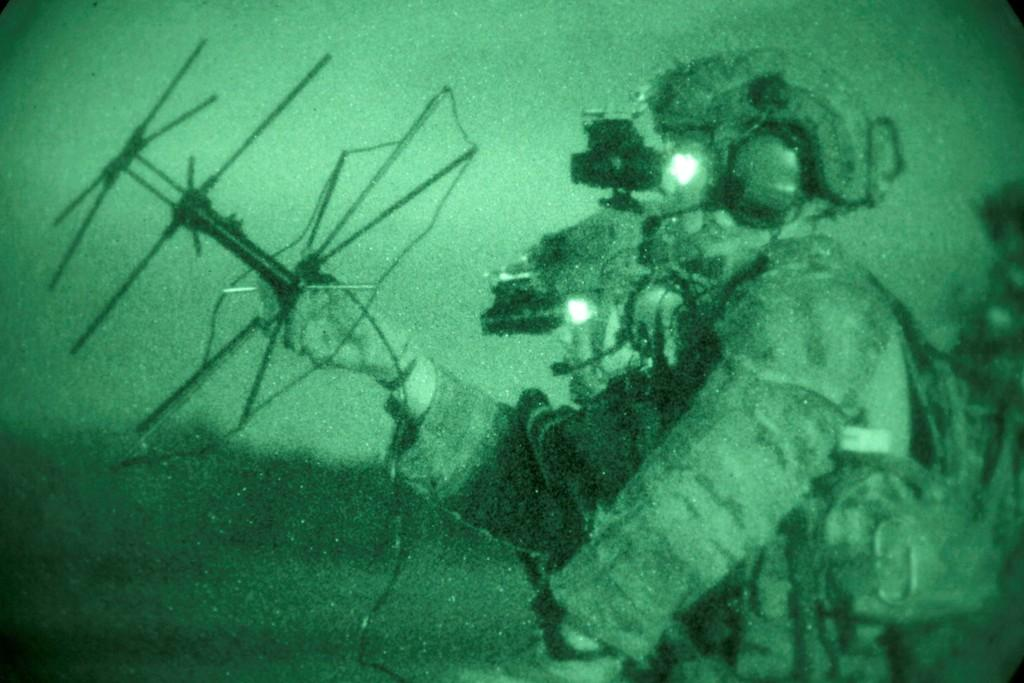What is the person in the image wearing? The person is wearing a dress and helmet in the image. What is the person holding in the image? The person is holding something in the image. What colors are used in the image? The image is in green and black color. What type of destruction is the woman causing in the image? There is no woman present in the image, and no destruction is depicted. 